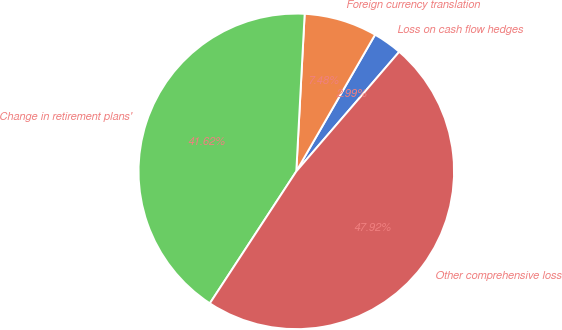Convert chart. <chart><loc_0><loc_0><loc_500><loc_500><pie_chart><fcel>Loss on cash flow hedges<fcel>Foreign currency translation<fcel>Change in retirement plans'<fcel>Other comprehensive loss<nl><fcel>2.99%<fcel>7.48%<fcel>41.62%<fcel>47.92%<nl></chart> 